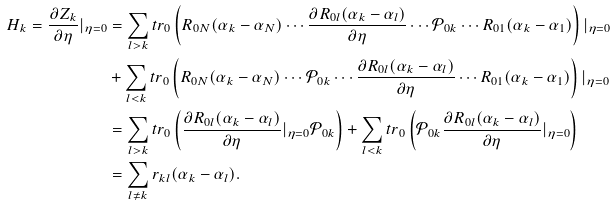Convert formula to latex. <formula><loc_0><loc_0><loc_500><loc_500>H _ { k } = \frac { \partial Z _ { k } } { \partial \eta } | _ { \eta = 0 } & = \sum _ { l > k } t r _ { 0 } \left ( R _ { 0 N } ( \alpha _ { k } - \alpha _ { N } ) \cdots \frac { \partial R _ { 0 l } ( \alpha _ { k } - \alpha _ { l } ) } { \partial \eta } \cdots \mathcal { P } _ { 0 k } \cdots R _ { 0 1 } ( \alpha _ { k } - \alpha _ { 1 } ) \right ) | _ { \eta = 0 } \\ & + \sum _ { l < k } t r _ { 0 } \left ( R _ { 0 N } ( \alpha _ { k } - \alpha _ { N } ) \cdots \mathcal { P } _ { 0 k } \cdots \frac { \partial R _ { 0 l } ( \alpha _ { k } - \alpha _ { l } ) } { \partial \eta } \cdots R _ { 0 1 } ( \alpha _ { k } - \alpha _ { 1 } ) \right ) | _ { \eta = 0 } \\ & = \sum _ { l > k } t r _ { 0 } \left ( \frac { \partial R _ { 0 l } ( \alpha _ { k } - \alpha _ { l } ) } { \partial \eta } | _ { \eta = 0 } \mathcal { P } _ { 0 k } \right ) + \sum _ { l < k } t r _ { 0 } \left ( \mathcal { P } _ { 0 k } \frac { \partial R _ { 0 l } ( \alpha _ { k } - \alpha _ { l } ) } { \partial \eta } | _ { \eta = 0 } \right ) \\ & = \sum _ { l \neq k } r _ { k l } ( \alpha _ { k } - \alpha _ { l } ) .</formula> 